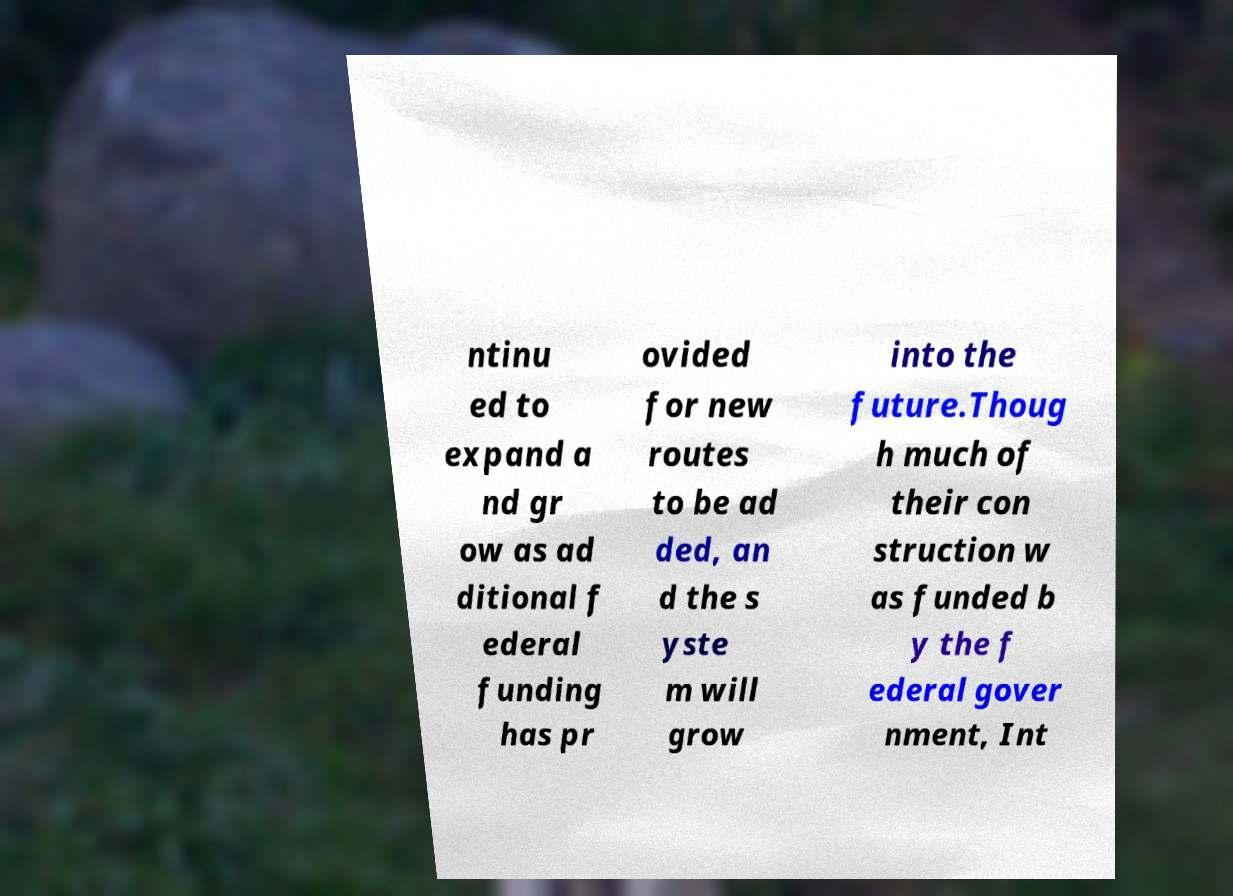I need the written content from this picture converted into text. Can you do that? ntinu ed to expand a nd gr ow as ad ditional f ederal funding has pr ovided for new routes to be ad ded, an d the s yste m will grow into the future.Thoug h much of their con struction w as funded b y the f ederal gover nment, Int 